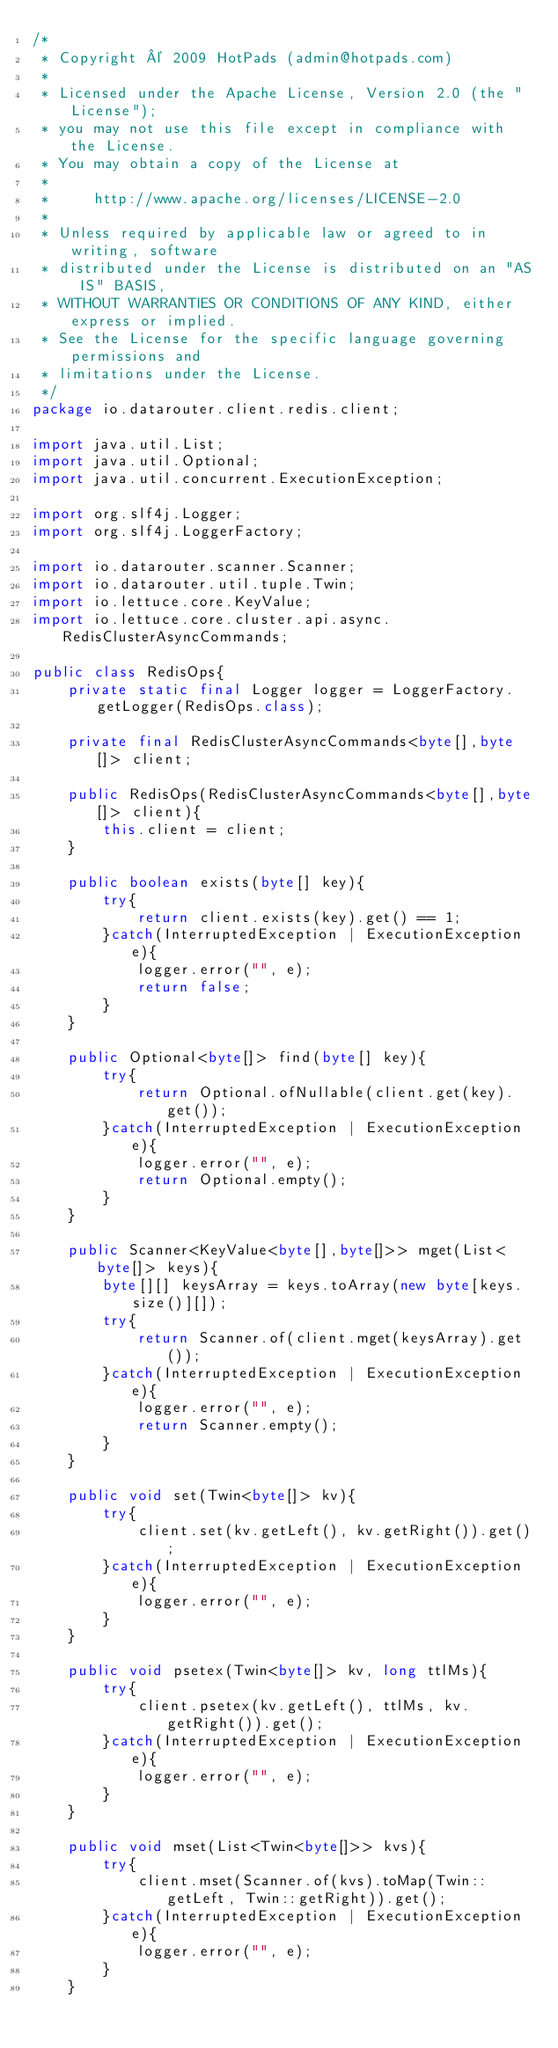<code> <loc_0><loc_0><loc_500><loc_500><_Java_>/*
 * Copyright © 2009 HotPads (admin@hotpads.com)
 *
 * Licensed under the Apache License, Version 2.0 (the "License");
 * you may not use this file except in compliance with the License.
 * You may obtain a copy of the License at
 *
 *     http://www.apache.org/licenses/LICENSE-2.0
 *
 * Unless required by applicable law or agreed to in writing, software
 * distributed under the License is distributed on an "AS IS" BASIS,
 * WITHOUT WARRANTIES OR CONDITIONS OF ANY KIND, either express or implied.
 * See the License for the specific language governing permissions and
 * limitations under the License.
 */
package io.datarouter.client.redis.client;

import java.util.List;
import java.util.Optional;
import java.util.concurrent.ExecutionException;

import org.slf4j.Logger;
import org.slf4j.LoggerFactory;

import io.datarouter.scanner.Scanner;
import io.datarouter.util.tuple.Twin;
import io.lettuce.core.KeyValue;
import io.lettuce.core.cluster.api.async.RedisClusterAsyncCommands;

public class RedisOps{
	private static final Logger logger = LoggerFactory.getLogger(RedisOps.class);

	private final RedisClusterAsyncCommands<byte[],byte[]> client;

	public RedisOps(RedisClusterAsyncCommands<byte[],byte[]> client){
		this.client = client;
	}

	public boolean exists(byte[] key){
		try{
			return client.exists(key).get() == 1;
		}catch(InterruptedException | ExecutionException e){
			logger.error("", e);
			return false;
		}
	}

	public Optional<byte[]> find(byte[] key){
		try{
			return Optional.ofNullable(client.get(key).get());
		}catch(InterruptedException | ExecutionException e){
			logger.error("", e);
			return Optional.empty();
		}
	}

	public Scanner<KeyValue<byte[],byte[]>> mget(List<byte[]> keys){
		byte[][] keysArray = keys.toArray(new byte[keys.size()][]);
		try{
			return Scanner.of(client.mget(keysArray).get());
		}catch(InterruptedException | ExecutionException e){
			logger.error("", e);
			return Scanner.empty();
		}
	}

	public void set(Twin<byte[]> kv){
		try{
			client.set(kv.getLeft(), kv.getRight()).get();
		}catch(InterruptedException | ExecutionException e){
			logger.error("", e);
		}
	}

	public void psetex(Twin<byte[]> kv, long ttlMs){
		try{
			client.psetex(kv.getLeft(), ttlMs, kv.getRight()).get();
		}catch(InterruptedException | ExecutionException e){
			logger.error("", e);
		}
	}

	public void mset(List<Twin<byte[]>> kvs){
		try{
			client.mset(Scanner.of(kvs).toMap(Twin::getLeft, Twin::getRight)).get();
		}catch(InterruptedException | ExecutionException e){
			logger.error("", e);
		}
	}
</code> 